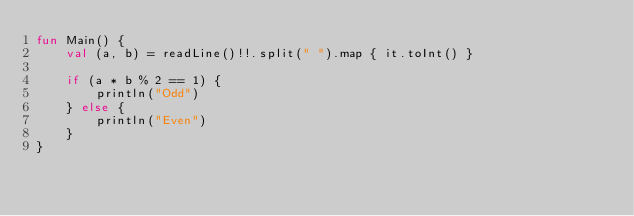<code> <loc_0><loc_0><loc_500><loc_500><_Kotlin_>fun Main() {
    val (a, b) = readLine()!!.split(" ").map { it.toInt() }

    if (a * b % 2 == 1) {
        println("Odd")
    } else {
        println("Even")
    }
}</code> 